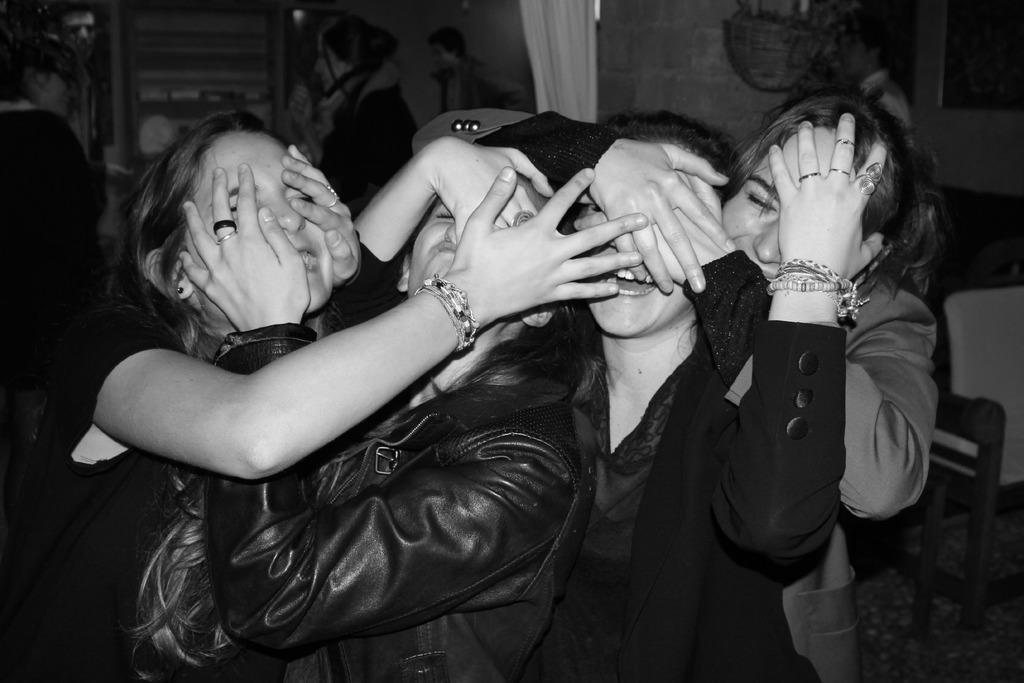Describe this image in one or two sentences. in this image there are four women's standing in middle of this image as we can see the left side three women's are wearing black color dress and there is a curtain in the top of the image and there is a wall in the background. 